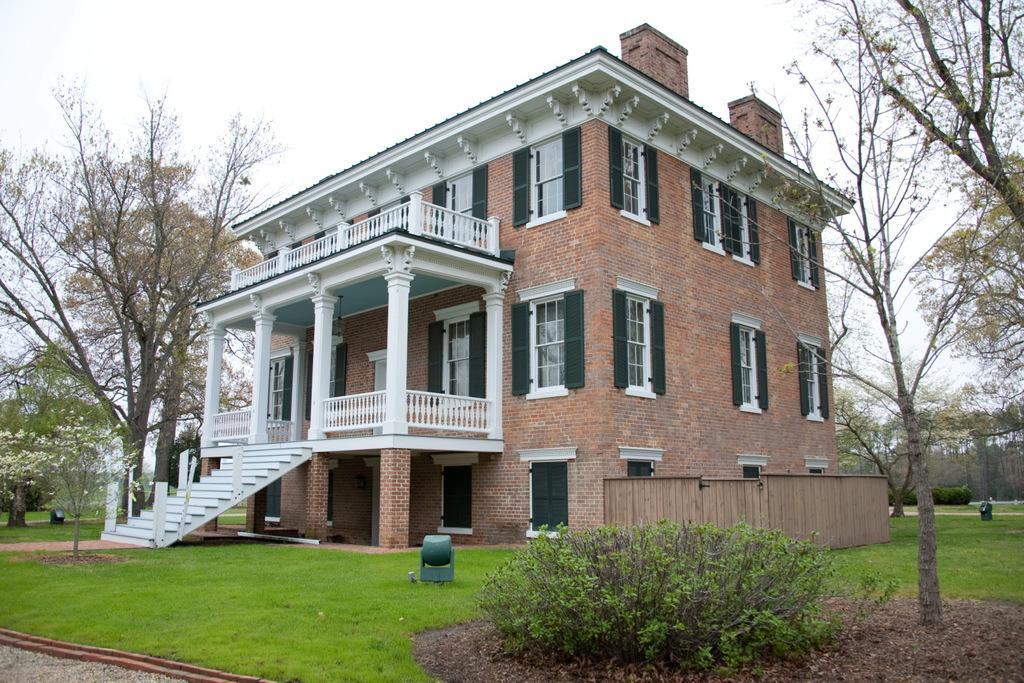In one or two sentences, can you explain what this image depicts? In the picture we can see a house, there is grass, there are some plants and in the background of the picture there are some trees and top of the picture there is cloudy sky. 